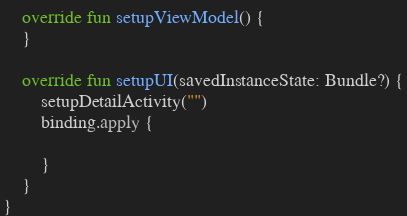<code> <loc_0><loc_0><loc_500><loc_500><_Kotlin_>
    override fun setupViewModel() {
    }

    override fun setupUI(savedInstanceState: Bundle?) {
        setupDetailActivity("")
        binding.apply {

        }
    }
}
</code> 